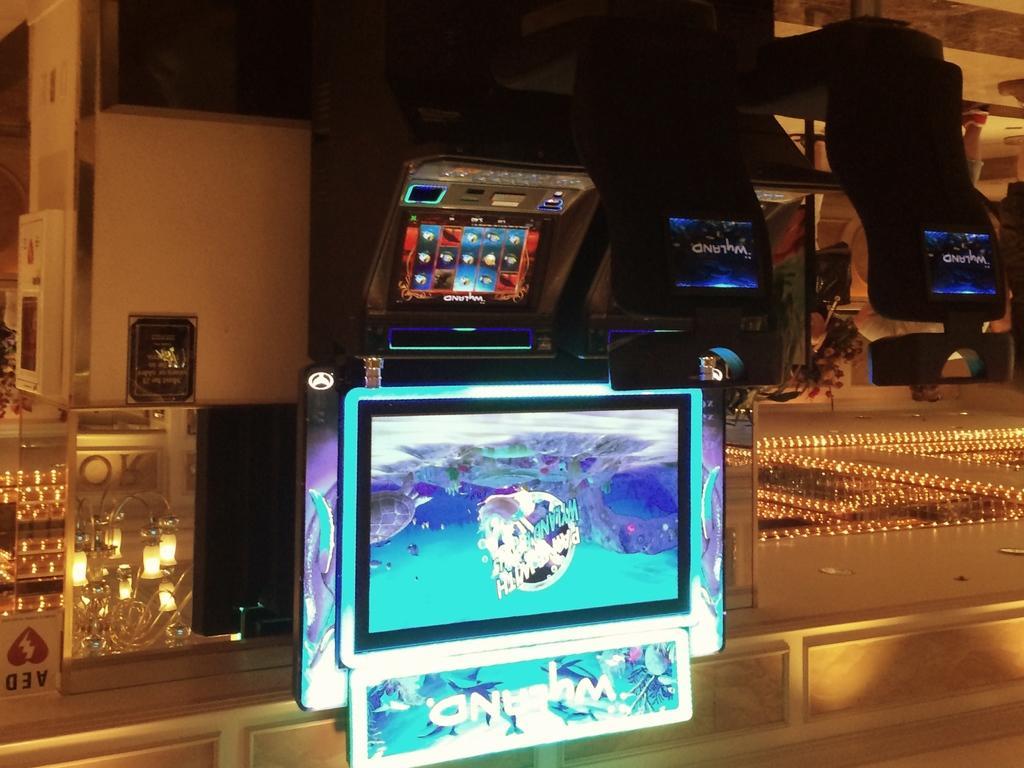Can you describe this image briefly? In this image we can see many screens, at the left there is a mirror, and lamp reflection on it, there are lights at the right, there is a wall. 